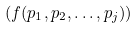<formula> <loc_0><loc_0><loc_500><loc_500>( f ( p _ { 1 } , p _ { 2 } , \dots , p _ { j } ) )</formula> 